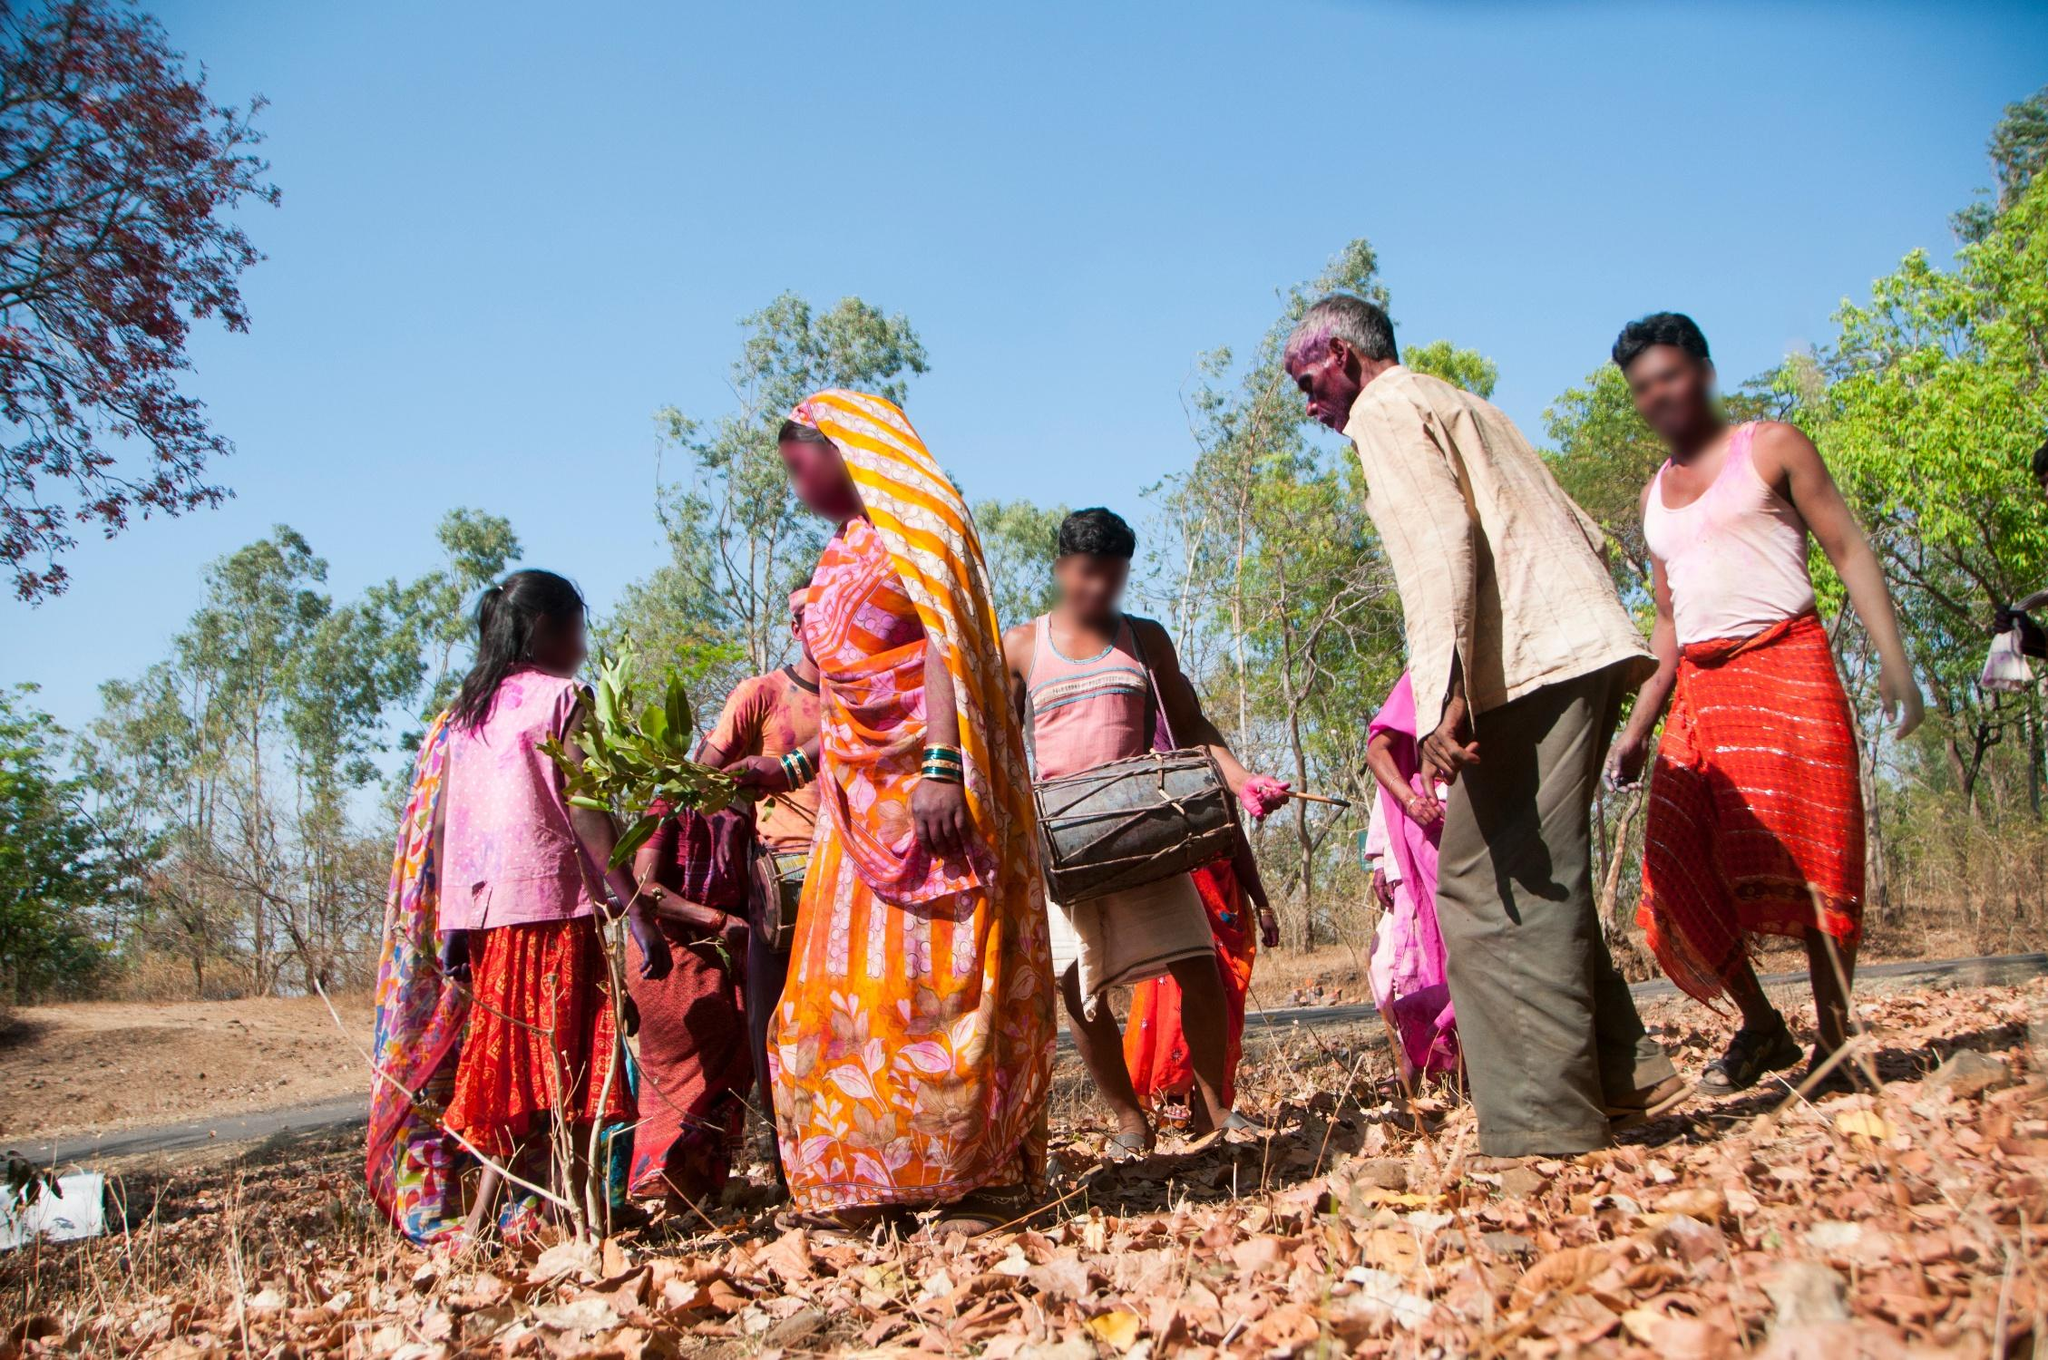If this scene were part of a story, what would the plot be? In the story, this scene would be set in a rural village where the community gathers to celebrate the annual harvest festival. Each year, families come together to work in the fields, collecting crops that will sustain them. This particular group, adorned in their most vibrant traditional attire, represents the village's heart and soul. As the day progresses, their hard work transitions into a festive celebration with songs, dance, and a communal feast, strengthening their bonds and honoring their heritage. 